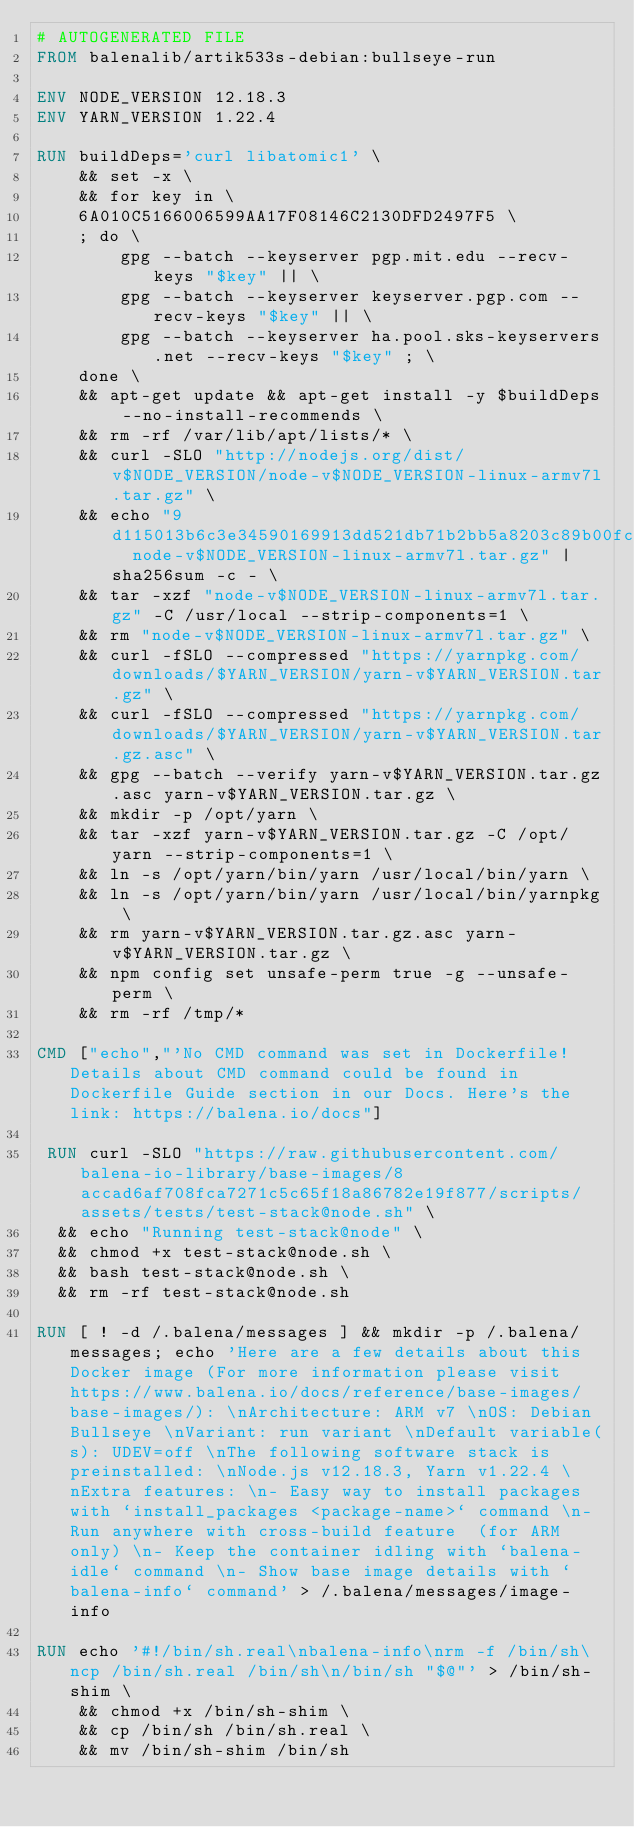<code> <loc_0><loc_0><loc_500><loc_500><_Dockerfile_># AUTOGENERATED FILE
FROM balenalib/artik533s-debian:bullseye-run

ENV NODE_VERSION 12.18.3
ENV YARN_VERSION 1.22.4

RUN buildDeps='curl libatomic1' \
	&& set -x \
	&& for key in \
	6A010C5166006599AA17F08146C2130DFD2497F5 \
	; do \
		gpg --batch --keyserver pgp.mit.edu --recv-keys "$key" || \
		gpg --batch --keyserver keyserver.pgp.com --recv-keys "$key" || \
		gpg --batch --keyserver ha.pool.sks-keyservers.net --recv-keys "$key" ; \
	done \
	&& apt-get update && apt-get install -y $buildDeps --no-install-recommends \
	&& rm -rf /var/lib/apt/lists/* \
	&& curl -SLO "http://nodejs.org/dist/v$NODE_VERSION/node-v$NODE_VERSION-linux-armv7l.tar.gz" \
	&& echo "9d115013b6c3e34590169913dd521db71b2bb5a8203c89b00fc94e32ecc9d642  node-v$NODE_VERSION-linux-armv7l.tar.gz" | sha256sum -c - \
	&& tar -xzf "node-v$NODE_VERSION-linux-armv7l.tar.gz" -C /usr/local --strip-components=1 \
	&& rm "node-v$NODE_VERSION-linux-armv7l.tar.gz" \
	&& curl -fSLO --compressed "https://yarnpkg.com/downloads/$YARN_VERSION/yarn-v$YARN_VERSION.tar.gz" \
	&& curl -fSLO --compressed "https://yarnpkg.com/downloads/$YARN_VERSION/yarn-v$YARN_VERSION.tar.gz.asc" \
	&& gpg --batch --verify yarn-v$YARN_VERSION.tar.gz.asc yarn-v$YARN_VERSION.tar.gz \
	&& mkdir -p /opt/yarn \
	&& tar -xzf yarn-v$YARN_VERSION.tar.gz -C /opt/yarn --strip-components=1 \
	&& ln -s /opt/yarn/bin/yarn /usr/local/bin/yarn \
	&& ln -s /opt/yarn/bin/yarn /usr/local/bin/yarnpkg \
	&& rm yarn-v$YARN_VERSION.tar.gz.asc yarn-v$YARN_VERSION.tar.gz \
	&& npm config set unsafe-perm true -g --unsafe-perm \
	&& rm -rf /tmp/*

CMD ["echo","'No CMD command was set in Dockerfile! Details about CMD command could be found in Dockerfile Guide section in our Docs. Here's the link: https://balena.io/docs"]

 RUN curl -SLO "https://raw.githubusercontent.com/balena-io-library/base-images/8accad6af708fca7271c5c65f18a86782e19f877/scripts/assets/tests/test-stack@node.sh" \
  && echo "Running test-stack@node" \
  && chmod +x test-stack@node.sh \
  && bash test-stack@node.sh \
  && rm -rf test-stack@node.sh 

RUN [ ! -d /.balena/messages ] && mkdir -p /.balena/messages; echo 'Here are a few details about this Docker image (For more information please visit https://www.balena.io/docs/reference/base-images/base-images/): \nArchitecture: ARM v7 \nOS: Debian Bullseye \nVariant: run variant \nDefault variable(s): UDEV=off \nThe following software stack is preinstalled: \nNode.js v12.18.3, Yarn v1.22.4 \nExtra features: \n- Easy way to install packages with `install_packages <package-name>` command \n- Run anywhere with cross-build feature  (for ARM only) \n- Keep the container idling with `balena-idle` command \n- Show base image details with `balena-info` command' > /.balena/messages/image-info

RUN echo '#!/bin/sh.real\nbalena-info\nrm -f /bin/sh\ncp /bin/sh.real /bin/sh\n/bin/sh "$@"' > /bin/sh-shim \
	&& chmod +x /bin/sh-shim \
	&& cp /bin/sh /bin/sh.real \
	&& mv /bin/sh-shim /bin/sh</code> 